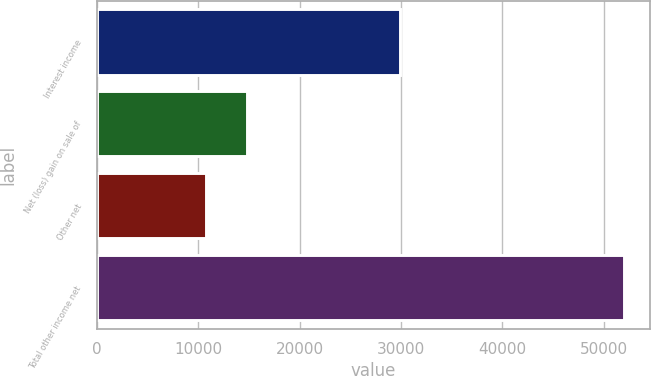Convert chart to OTSL. <chart><loc_0><loc_0><loc_500><loc_500><bar_chart><fcel>Interest income<fcel>Net (loss) gain on sale of<fcel>Other net<fcel>Total other income net<nl><fcel>29924<fcel>14863.4<fcel>10740<fcel>51974<nl></chart> 